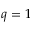Convert formula to latex. <formula><loc_0><loc_0><loc_500><loc_500>q = 1</formula> 